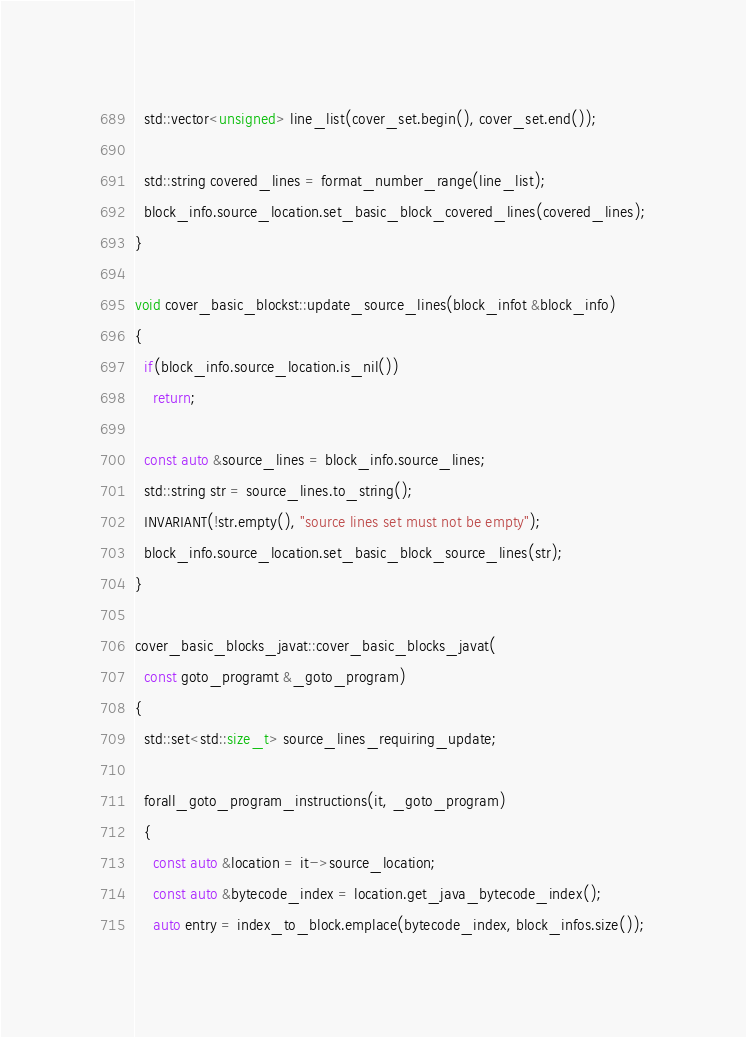Convert code to text. <code><loc_0><loc_0><loc_500><loc_500><_C++_>  std::vector<unsigned> line_list(cover_set.begin(), cover_set.end());

  std::string covered_lines = format_number_range(line_list);
  block_info.source_location.set_basic_block_covered_lines(covered_lines);
}

void cover_basic_blockst::update_source_lines(block_infot &block_info)
{
  if(block_info.source_location.is_nil())
    return;

  const auto &source_lines = block_info.source_lines;
  std::string str = source_lines.to_string();
  INVARIANT(!str.empty(), "source lines set must not be empty");
  block_info.source_location.set_basic_block_source_lines(str);
}

cover_basic_blocks_javat::cover_basic_blocks_javat(
  const goto_programt &_goto_program)
{
  std::set<std::size_t> source_lines_requiring_update;

  forall_goto_program_instructions(it, _goto_program)
  {
    const auto &location = it->source_location;
    const auto &bytecode_index = location.get_java_bytecode_index();
    auto entry = index_to_block.emplace(bytecode_index, block_infos.size());</code> 